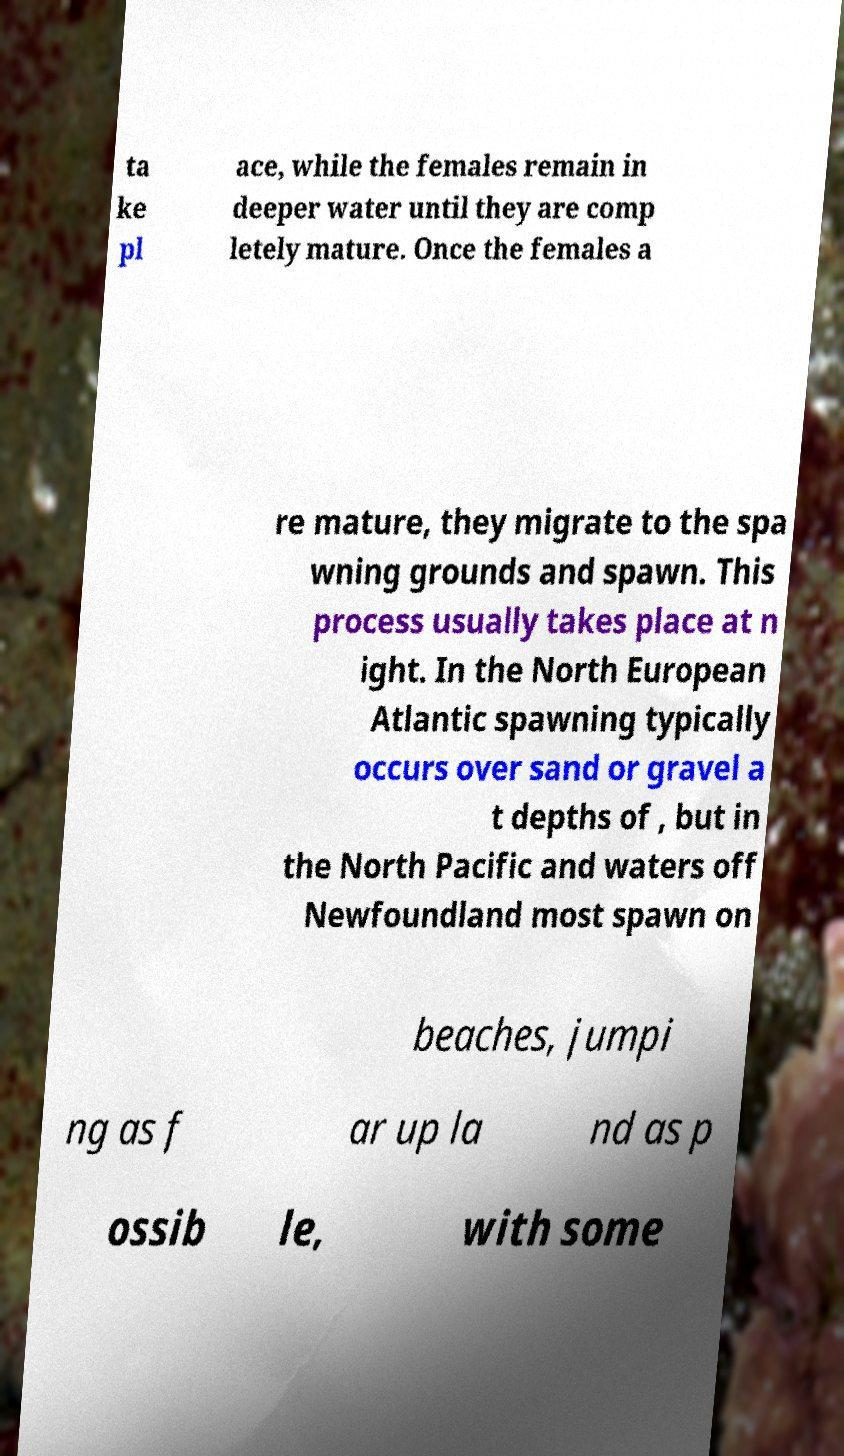There's text embedded in this image that I need extracted. Can you transcribe it verbatim? ta ke pl ace, while the females remain in deeper water until they are comp letely mature. Once the females a re mature, they migrate to the spa wning grounds and spawn. This process usually takes place at n ight. In the North European Atlantic spawning typically occurs over sand or gravel a t depths of , but in the North Pacific and waters off Newfoundland most spawn on beaches, jumpi ng as f ar up la nd as p ossib le, with some 